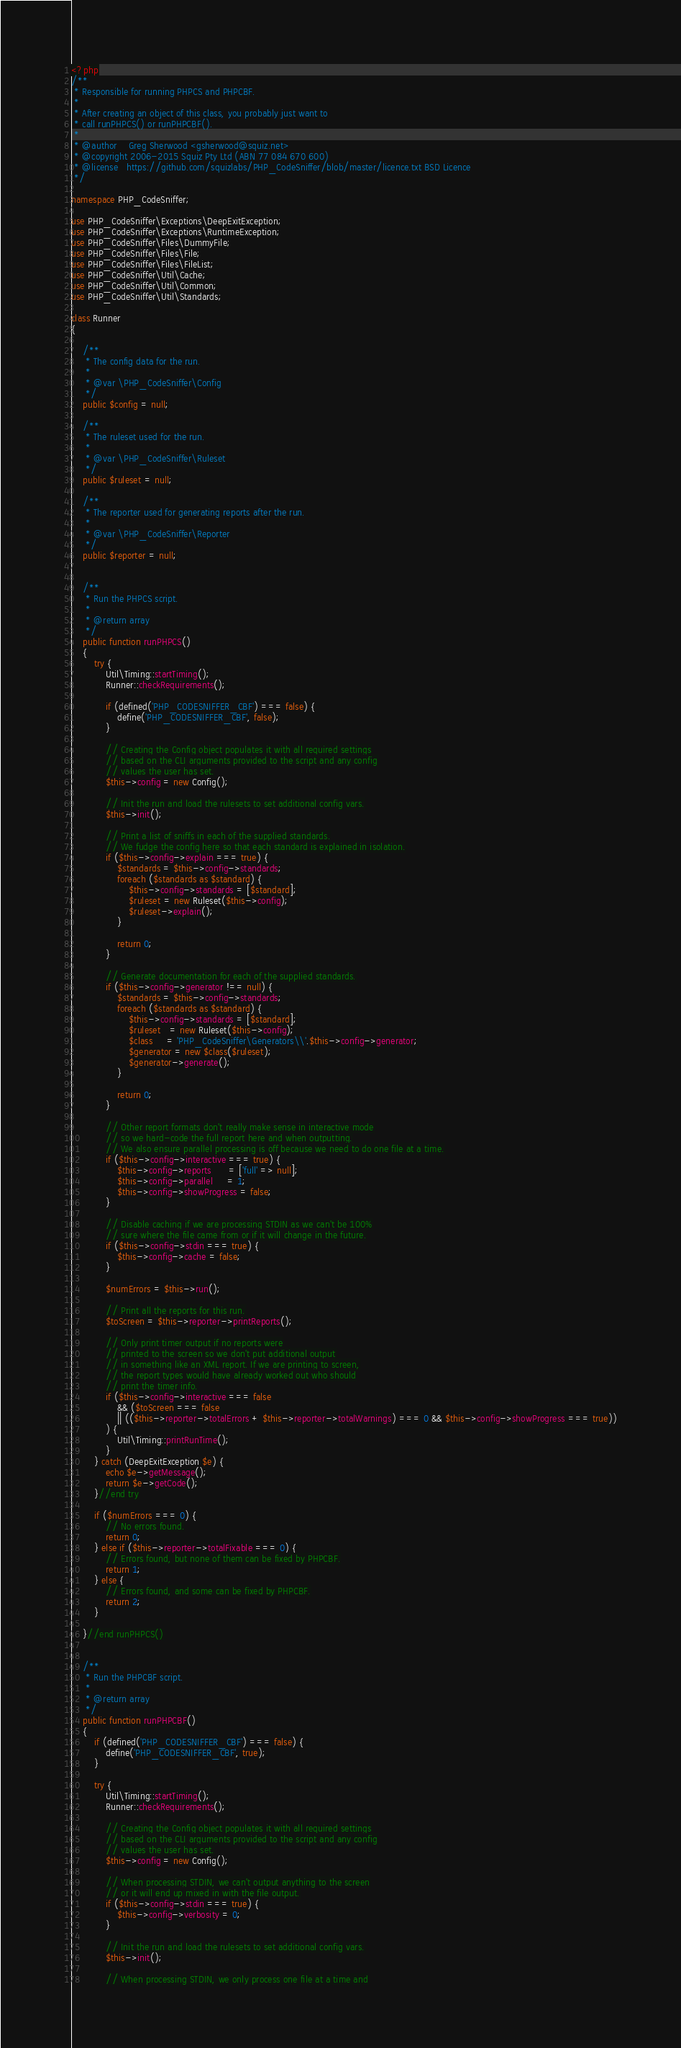<code> <loc_0><loc_0><loc_500><loc_500><_PHP_><?php
/**
 * Responsible for running PHPCS and PHPCBF.
 *
 * After creating an object of this class, you probably just want to
 * call runPHPCS() or runPHPCBF().
 *
 * @author    Greg Sherwood <gsherwood@squiz.net>
 * @copyright 2006-2015 Squiz Pty Ltd (ABN 77 084 670 600)
 * @license   https://github.com/squizlabs/PHP_CodeSniffer/blob/master/licence.txt BSD Licence
 */

namespace PHP_CodeSniffer;

use PHP_CodeSniffer\Exceptions\DeepExitException;
use PHP_CodeSniffer\Exceptions\RuntimeException;
use PHP_CodeSniffer\Files\DummyFile;
use PHP_CodeSniffer\Files\File;
use PHP_CodeSniffer\Files\FileList;
use PHP_CodeSniffer\Util\Cache;
use PHP_CodeSniffer\Util\Common;
use PHP_CodeSniffer\Util\Standards;

class Runner
{

    /**
     * The config data for the run.
     *
     * @var \PHP_CodeSniffer\Config
     */
    public $config = null;

    /**
     * The ruleset used for the run.
     *
     * @var \PHP_CodeSniffer\Ruleset
     */
    public $ruleset = null;

    /**
     * The reporter used for generating reports after the run.
     *
     * @var \PHP_CodeSniffer\Reporter
     */
    public $reporter = null;


    /**
     * Run the PHPCS script.
     *
     * @return array
     */
    public function runPHPCS()
    {
        try {
            Util\Timing::startTiming();
            Runner::checkRequirements();

            if (defined('PHP_CODESNIFFER_CBF') === false) {
                define('PHP_CODESNIFFER_CBF', false);
            }

            // Creating the Config object populates it with all required settings
            // based on the CLI arguments provided to the script and any config
            // values the user has set.
            $this->config = new Config();

            // Init the run and load the rulesets to set additional config vars.
            $this->init();

            // Print a list of sniffs in each of the supplied standards.
            // We fudge the config here so that each standard is explained in isolation.
            if ($this->config->explain === true) {
                $standards = $this->config->standards;
                foreach ($standards as $standard) {
                    $this->config->standards = [$standard];
                    $ruleset = new Ruleset($this->config);
                    $ruleset->explain();
                }

                return 0;
            }

            // Generate documentation for each of the supplied standards.
            if ($this->config->generator !== null) {
                $standards = $this->config->standards;
                foreach ($standards as $standard) {
                    $this->config->standards = [$standard];
                    $ruleset   = new Ruleset($this->config);
                    $class     = 'PHP_CodeSniffer\Generators\\'.$this->config->generator;
                    $generator = new $class($ruleset);
                    $generator->generate();
                }

                return 0;
            }

            // Other report formats don't really make sense in interactive mode
            // so we hard-code the full report here and when outputting.
            // We also ensure parallel processing is off because we need to do one file at a time.
            if ($this->config->interactive === true) {
                $this->config->reports      = ['full' => null];
                $this->config->parallel     = 1;
                $this->config->showProgress = false;
            }

            // Disable caching if we are processing STDIN as we can't be 100%
            // sure where the file came from or if it will change in the future.
            if ($this->config->stdin === true) {
                $this->config->cache = false;
            }

            $numErrors = $this->run();

            // Print all the reports for this run.
            $toScreen = $this->reporter->printReports();

            // Only print timer output if no reports were
            // printed to the screen so we don't put additional output
            // in something like an XML report. If we are printing to screen,
            // the report types would have already worked out who should
            // print the timer info.
            if ($this->config->interactive === false
                && ($toScreen === false
                || (($this->reporter->totalErrors + $this->reporter->totalWarnings) === 0 && $this->config->showProgress === true))
            ) {
                Util\Timing::printRunTime();
            }
        } catch (DeepExitException $e) {
            echo $e->getMessage();
            return $e->getCode();
        }//end try

        if ($numErrors === 0) {
            // No errors found.
            return 0;
        } else if ($this->reporter->totalFixable === 0) {
            // Errors found, but none of them can be fixed by PHPCBF.
            return 1;
        } else {
            // Errors found, and some can be fixed by PHPCBF.
            return 2;
        }

    }//end runPHPCS()


    /**
     * Run the PHPCBF script.
     *
     * @return array
     */
    public function runPHPCBF()
    {
        if (defined('PHP_CODESNIFFER_CBF') === false) {
            define('PHP_CODESNIFFER_CBF', true);
        }

        try {
            Util\Timing::startTiming();
            Runner::checkRequirements();

            // Creating the Config object populates it with all required settings
            // based on the CLI arguments provided to the script and any config
            // values the user has set.
            $this->config = new Config();

            // When processing STDIN, we can't output anything to the screen
            // or it will end up mixed in with the file output.
            if ($this->config->stdin === true) {
                $this->config->verbosity = 0;
            }

            // Init the run and load the rulesets to set additional config vars.
            $this->init();

            // When processing STDIN, we only process one file at a time and</code> 